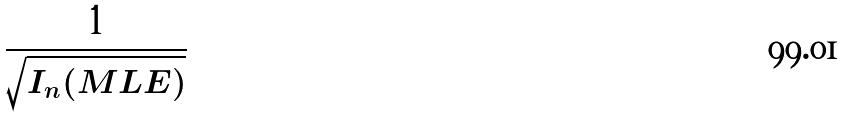Convert formula to latex. <formula><loc_0><loc_0><loc_500><loc_500>\frac { 1 } { \sqrt { I _ { n } ( M L E ) } }</formula> 